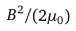<formula> <loc_0><loc_0><loc_500><loc_500>B ^ { 2 } / ( 2 \mu _ { 0 } )</formula> 